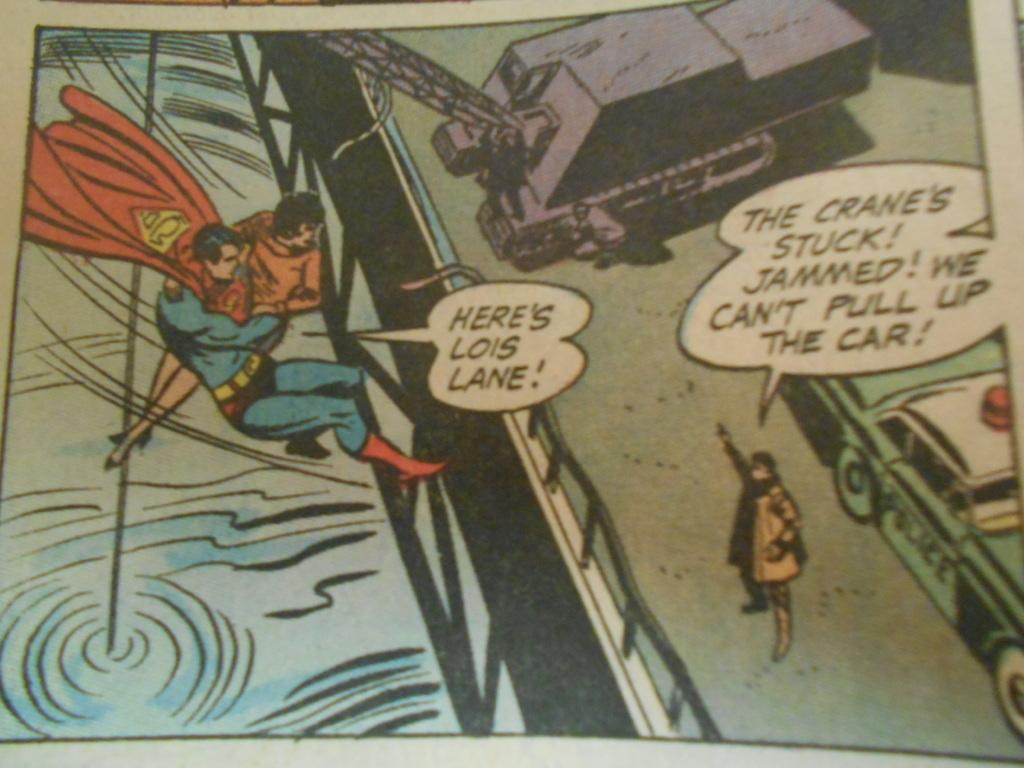<image>
Summarize the visual content of the image. A comic book panel of Superman saving Lois Lane. 